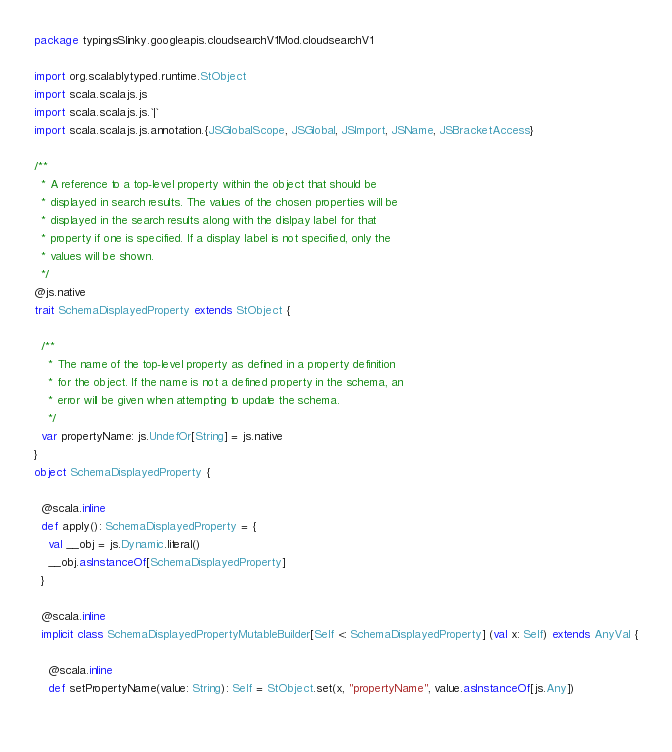Convert code to text. <code><loc_0><loc_0><loc_500><loc_500><_Scala_>package typingsSlinky.googleapis.cloudsearchV1Mod.cloudsearchV1

import org.scalablytyped.runtime.StObject
import scala.scalajs.js
import scala.scalajs.js.`|`
import scala.scalajs.js.annotation.{JSGlobalScope, JSGlobal, JSImport, JSName, JSBracketAccess}

/**
  * A reference to a top-level property within the object that should be
  * displayed in search results. The values of the chosen properties will be
  * displayed in the search results along with the dislpay label for that
  * property if one is specified. If a display label is not specified, only the
  * values will be shown.
  */
@js.native
trait SchemaDisplayedProperty extends StObject {
  
  /**
    * The name of the top-level property as defined in a property definition
    * for the object. If the name is not a defined property in the schema, an
    * error will be given when attempting to update the schema.
    */
  var propertyName: js.UndefOr[String] = js.native
}
object SchemaDisplayedProperty {
  
  @scala.inline
  def apply(): SchemaDisplayedProperty = {
    val __obj = js.Dynamic.literal()
    __obj.asInstanceOf[SchemaDisplayedProperty]
  }
  
  @scala.inline
  implicit class SchemaDisplayedPropertyMutableBuilder[Self <: SchemaDisplayedProperty] (val x: Self) extends AnyVal {
    
    @scala.inline
    def setPropertyName(value: String): Self = StObject.set(x, "propertyName", value.asInstanceOf[js.Any])
    </code> 